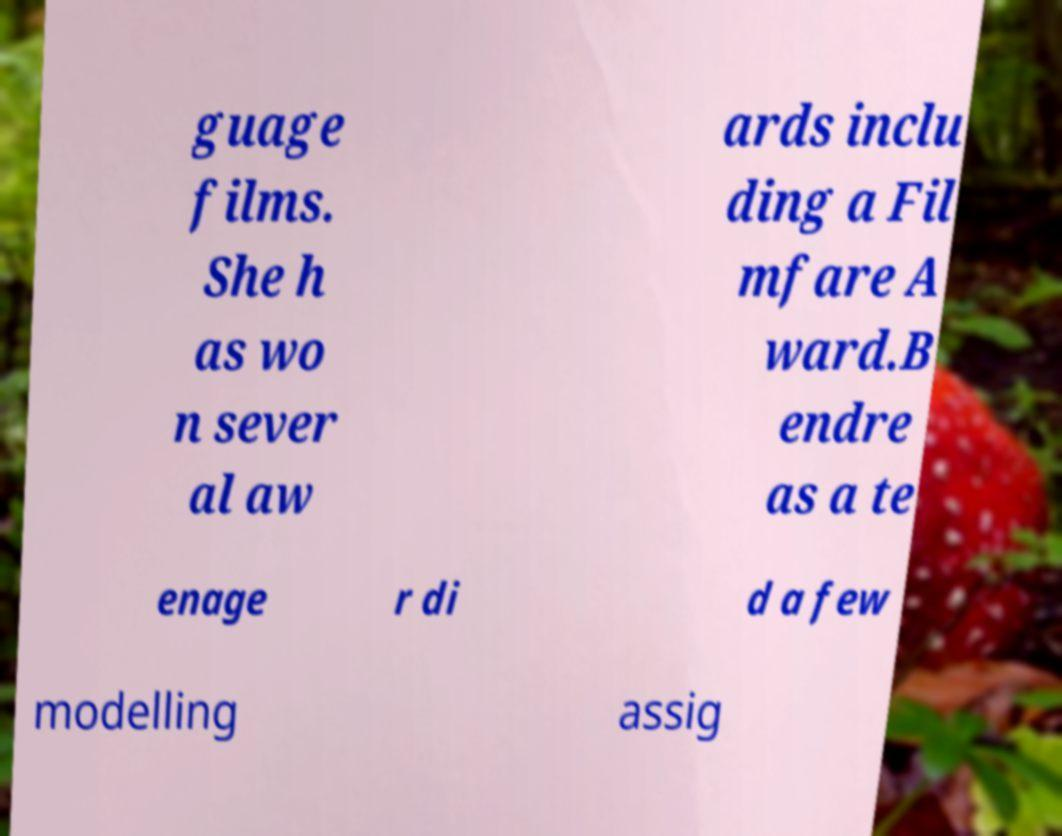Please read and relay the text visible in this image. What does it say? guage films. She h as wo n sever al aw ards inclu ding a Fil mfare A ward.B endre as a te enage r di d a few modelling assig 